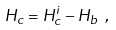Convert formula to latex. <formula><loc_0><loc_0><loc_500><loc_500>H _ { c } = H _ { c } ^ { i } - H _ { b } \ ,</formula> 